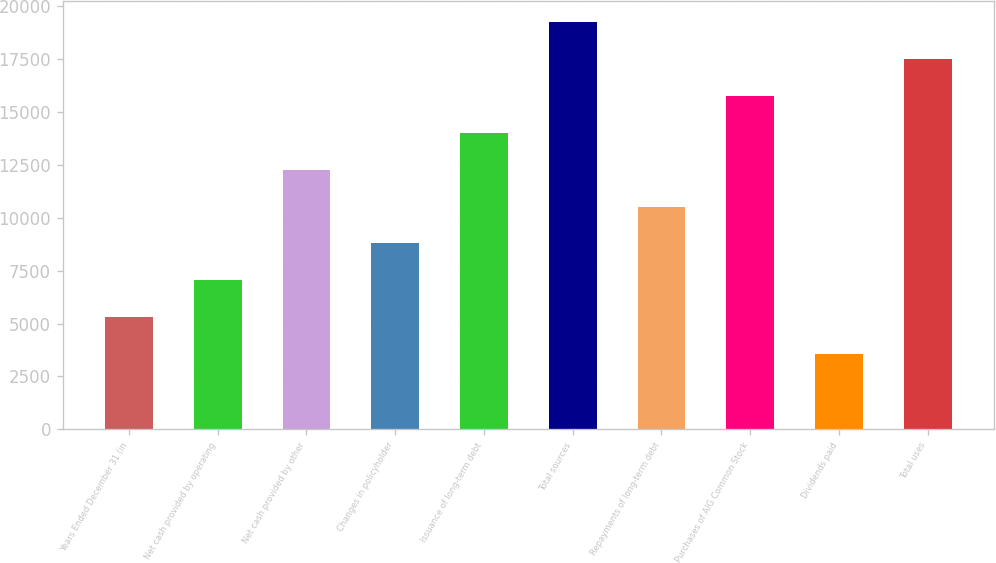Convert chart to OTSL. <chart><loc_0><loc_0><loc_500><loc_500><bar_chart><fcel>Years Ended December 31 (in<fcel>Net cash provided by operating<fcel>Net cash provided by other<fcel>Changes in policyholder<fcel>Issuance of long-term debt<fcel>Total sources<fcel>Repayments of long-term debt<fcel>Purchases of AIG Common Stock<fcel>Dividends paid<fcel>Total uses<nl><fcel>5291.5<fcel>7038<fcel>12277.5<fcel>8784.5<fcel>14024<fcel>19263.5<fcel>10531<fcel>15770.5<fcel>3545<fcel>17517<nl></chart> 